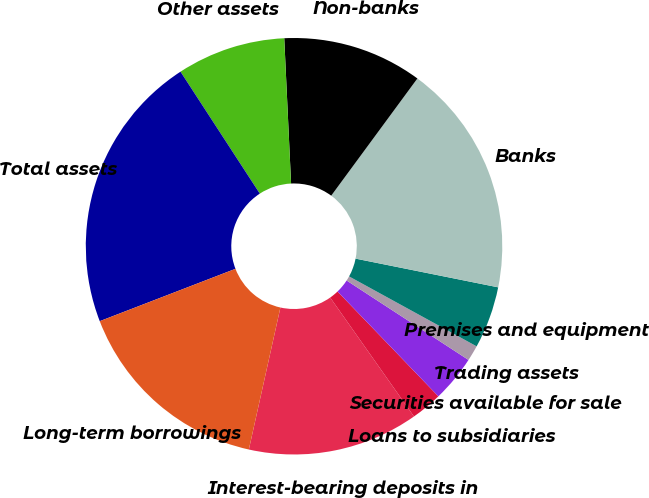Convert chart to OTSL. <chart><loc_0><loc_0><loc_500><loc_500><pie_chart><fcel>Interest-bearing deposits in<fcel>Loans to subsidiaries<fcel>Securities available for sale<fcel>Trading assets<fcel>Premises and equipment<fcel>Banks<fcel>Non-banks<fcel>Other assets<fcel>Total assets<fcel>Long-term borrowings<nl><fcel>13.25%<fcel>2.42%<fcel>3.62%<fcel>1.21%<fcel>4.82%<fcel>18.07%<fcel>10.84%<fcel>8.43%<fcel>21.68%<fcel>15.66%<nl></chart> 